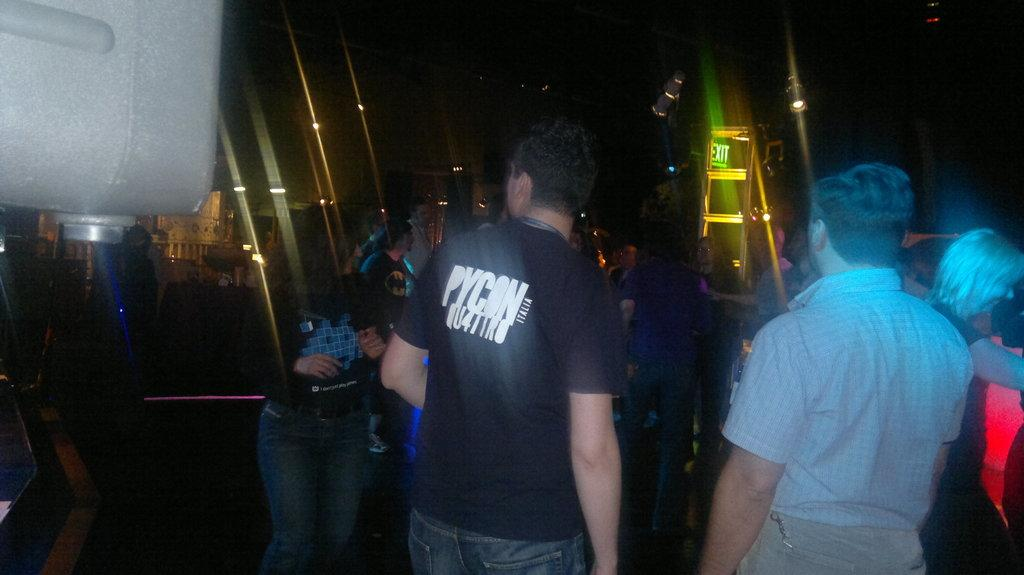What are the people in the foreground of the picture doing? The people in the foreground of the picture are dancing. What can be seen in the background of the picture? There are lights and buildings in the background of the picture. How would you describe the lighting in the top part of the image? The top part of the image is dark. What type of feast is being prepared on the grass in the image? There is no feast or grass present in the image; it features people dancing in the foreground and lights and buildings in the background. 